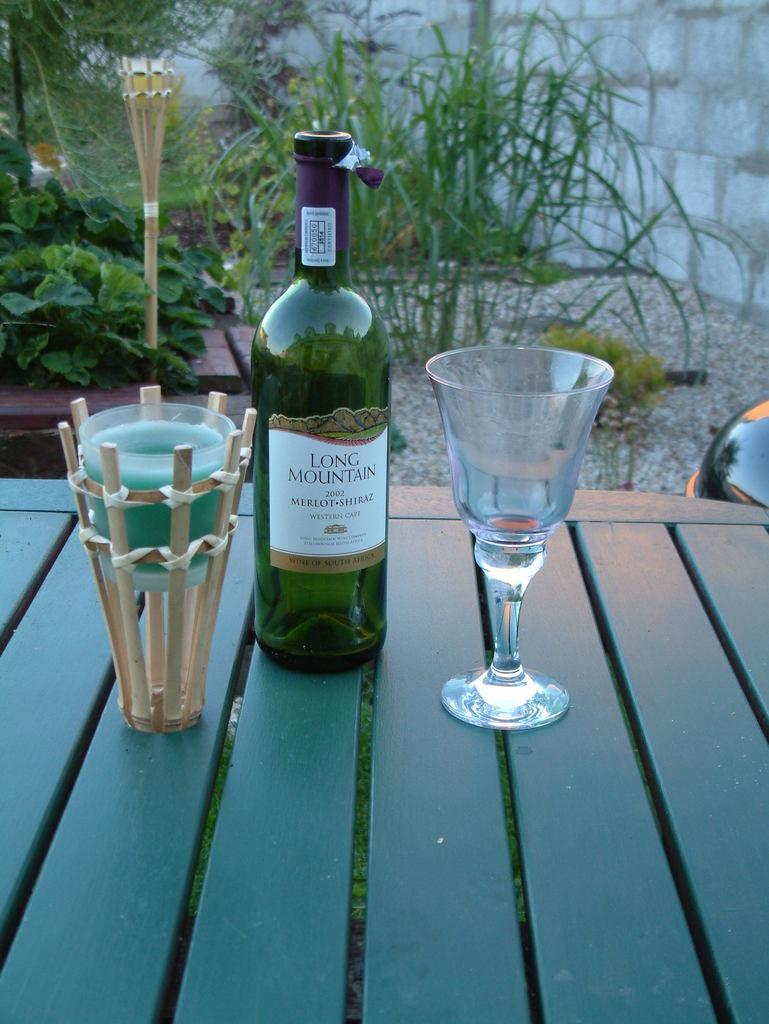What is on the table in the image? There is a bottle and a glass on the table in the image. Can you describe the background of the image? There are plants visible in the background of the image. What type of wrist injury can be seen on the person in the image? There is no person present in the image, and therefore no wrist injury can be observed. 